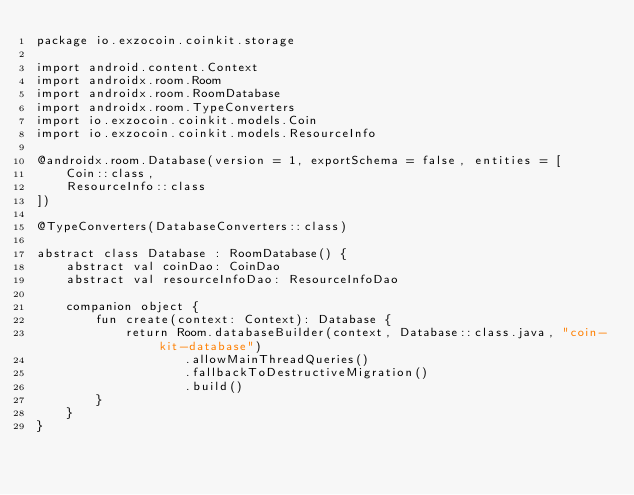<code> <loc_0><loc_0><loc_500><loc_500><_Kotlin_>package io.exzocoin.coinkit.storage

import android.content.Context
import androidx.room.Room
import androidx.room.RoomDatabase
import androidx.room.TypeConverters
import io.exzocoin.coinkit.models.Coin
import io.exzocoin.coinkit.models.ResourceInfo

@androidx.room.Database(version = 1, exportSchema = false, entities = [
    Coin::class,
    ResourceInfo::class
])

@TypeConverters(DatabaseConverters::class)

abstract class Database : RoomDatabase() {
    abstract val coinDao: CoinDao
    abstract val resourceInfoDao: ResourceInfoDao

    companion object {
        fun create(context: Context): Database {
            return Room.databaseBuilder(context, Database::class.java, "coin-kit-database")
                    .allowMainThreadQueries()
                    .fallbackToDestructiveMigration()
                    .build()
        }
    }
}
</code> 